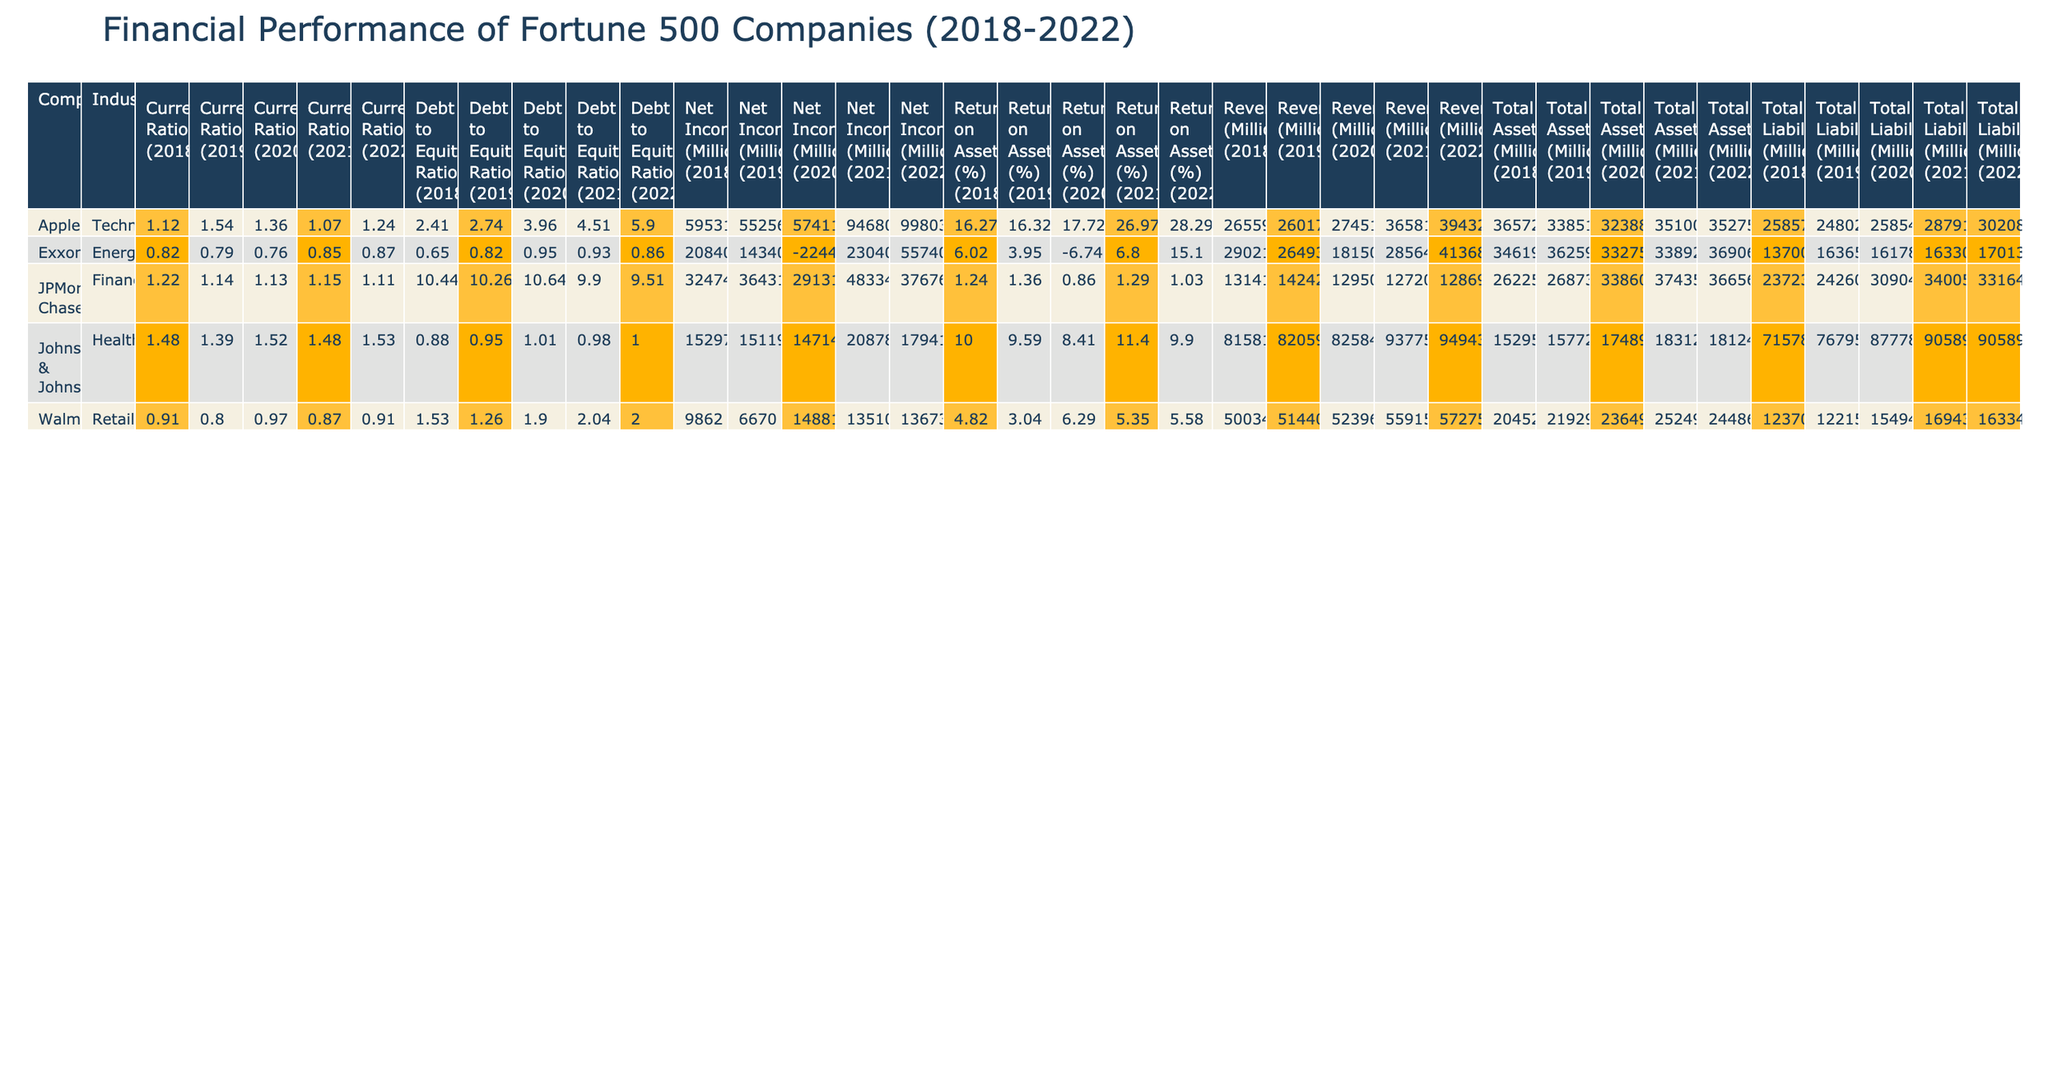What company had the highest revenue in 2021? By scanning the Revenue column for the year 2021, Apple has the highest revenue with 365,817 million dollars.
Answer: Apple What was the total net income of Walmart from 2018 to 2022? The net income for Walmart over these years is (9,862 + 6,670 + 14,881 + 13,510 + 13,673) = 58,596 million dollars in total.
Answer: 58,596 Is Johnson & Johnson's Return on Assets increasing over the five-year period? Looking at the Return on Assets for Johnson & Johnson from 2018 to 2022, the percentages are 10.00, 9.59, 8.41, 11.40, and 9.90 respectively. Since the overall trend shows ups and downs without a consistent increase, the answer is no.
Answer: No Which industry had the lowest debt to equity ratio in 2020? The debt to equity ratio values in 2020 are as follows: Technology (3.96), Retail (1.90), Energy (0.95), Finance (10.64), and Healthcare (1.01). The lowest among these is Energy with a ratio of 0.95.
Answer: Energy What is the average current ratio for ExxonMobil from 2018 to 2022? The current ratios for ExxonMobil over these years are 0.82, 0.79, 0.76, 0.85, and 0.87. Adding these values gives 0.82 + 0.79 + 0.76 + 0.85 + 0.87 = 4.09. To find the average, divide by 5: 4.09 / 5 = 0.818.
Answer: 0.818 Did JPMorgan Chase have a net income higher than ExxonMobil in 2022? In 2022, JPMorgan Chase's net income was 37,676 million dollars while ExxonMobil's net income was 55,740 million dollars. Comparing these figures shows that ExxonMobil had a higher net income.
Answer: No How much did Apple’s total assets increase from 2018 to 2022? The total assets for Apple in 2018 were 365,725 million dollars, and in 2022, it was 352,755 million dollars. The increase can be calculated as 352,755 - 365,725 which equals a decrease of 12,970 million dollars.
Answer: Decrease of 12,970 Which company has the highest return on assets in 2022? Reviewing the Return on Assets for 2022 shows Apple had 28.29%, Walmart 5.58%, ExxonMobil 15.10%, JPMorgan Chase 1.03%, and Johnson & Johnson 9.90%. Apple clearly has the highest percentage at 28.29%.
Answer: Apple 